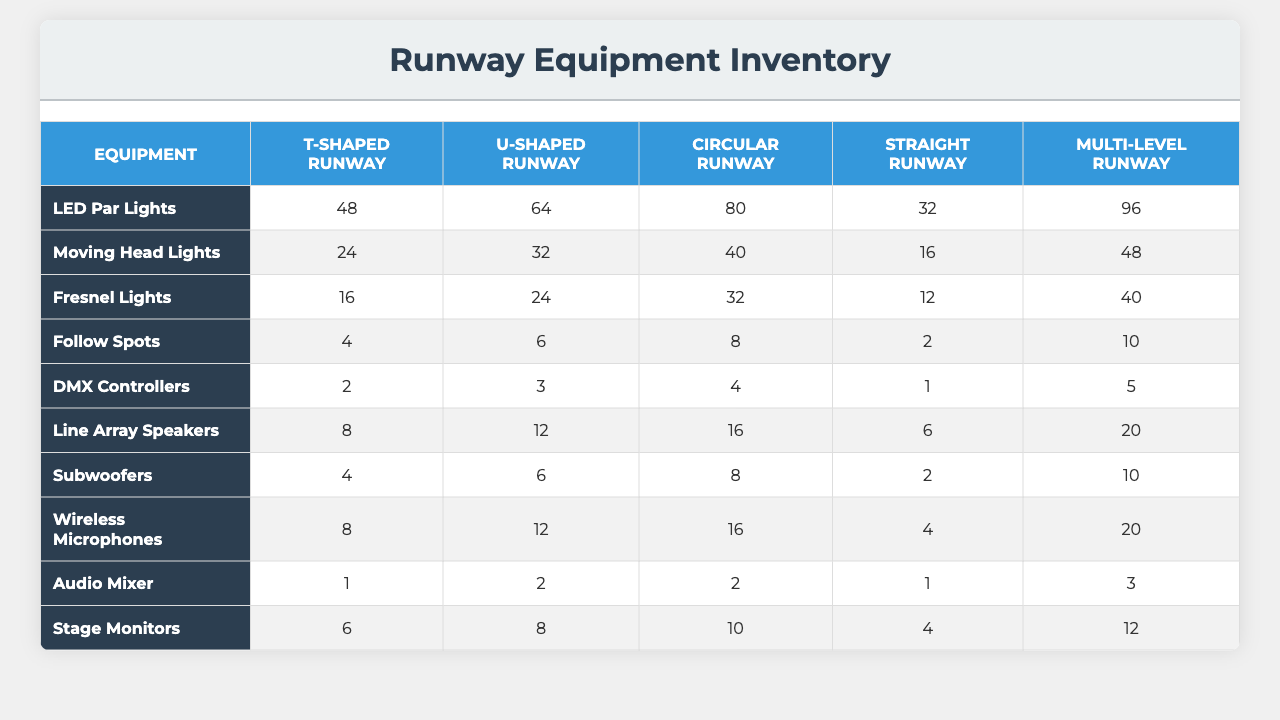What is the total number of LED Par Lights needed for all runway configurations? According to the table, the quantities for LED Par Lights in each configuration are: 48 (T-shaped), 64 (U-shaped), 80 (Circular), 32 (Straight), and 96 (Multi-level). Adding these up: 48 + 64 + 80 + 32 + 96 = 320.
Answer: 320 Which runway configuration requires the most Follow Spots? Referring to the table for Follow Spots, the quantities are: 4 (T-shaped), 6 (U-shaped), 8 (Circular), 2 (Straight), and 10 (Multi-level). The highest quantity is 10 for Multi-level.
Answer: Multi-level What is the average number of Subwoofers across all configurations? The quantities for Subwoofers in each configuration are 4 (T-shaped), 6 (U-shaped), 8 (Circular), 2 (Straight), and 10 (Multi-level). We sum these: 4 + 6 + 8 + 2 + 10 = 30. Since there are 5 configurations, the average is 30 / 5 = 6.
Answer: 6 Which equipment type is most abundant in the Circular Runway configuration? Looking at the Circular Runway configuration, the quantities are: LED Par Lights (80), Moving Head Lights (40), Fresnel Lights (32), Follow Spots (8), DMX Controllers (4), Line Array Speakers (16), Subwoofers (8), Wireless Microphones (16), Audio Mixer (2), and Stage Monitors (10). The highest number is 80 for LED Par Lights.
Answer: LED Par Lights How many more Moving Head Lights does the U-shaped configuration have compared to the Straight configuration? The U-shaped configuration has 32 Moving Head Lights, while the Straight configuration has 16. To find the difference, we subtract: 32 - 16 = 16.
Answer: 16 What percentage of total Wireless Microphones does the T-shaped configuration have? The total number of Wireless Microphones across all configurations is 4 (T-shaped) + 6 (U-shaped) + 8 (Circular) + 2 (Straight) + 10 (Multi-level) = 30. The T-shaped configuration has 4, so the percentage is (4/30) * 100 = 13.33%.
Answer: 13.33% How do the total quantities of Fresnel Lights compare between the U-shaped and Multi-level configurations? The U-shaped configuration has 24 Fresnel Lights, whereas the Multi-level configuration has 40. We find the difference: 40 - 24 = 16, meaning Multi-level has 16 more Fresnel Lights than U-shaped.
Answer: 16 more Fresnel Lights Is the total quantity of audio mixers across all configurations greater than that of subwoofers? The total quantity of Audio Mixers is 1 (T-shaped) + 2 (U-shaped) + 2 (Circular) + 1 (Straight) + 3 (Multi-level) = 9. The total quantity of subwoofers is 4 + 6 + 8 + 2 + 10 = 30. Since 9 is less than 30, the statement is true.
Answer: Yes What is the total number of lighting equipment items (LED Par Lights, Moving Head Lights, Fresnel Lights, Follow Spots, and DMX Controllers) needed for a T-shaped runway? The quantities for lighting equipment in the T-shaped configuration are: LED Par Lights (48), Moving Head Lights (24), Fresnel Lights (16), Follow Spots (4), and DMX Controllers (2). Summing these gives: 48 + 24 + 16 + 4 + 2 = 94.
Answer: 94 How many more total lighting items are there in a Multi-level configuration than in a Straight configuration? The total number of lighting items for Multi-level is 96 (LED Par Lights) + 48 (Moving Head Lights) + 40 (Fresnel Lights) + 10 (Follow Spots) + 5 (DMX Controllers) = 199. The total for Straight is 32 + 16 + 12 + 2 + 1 = 63. To get the difference, we compute 199 - 63 = 136.
Answer: 136 